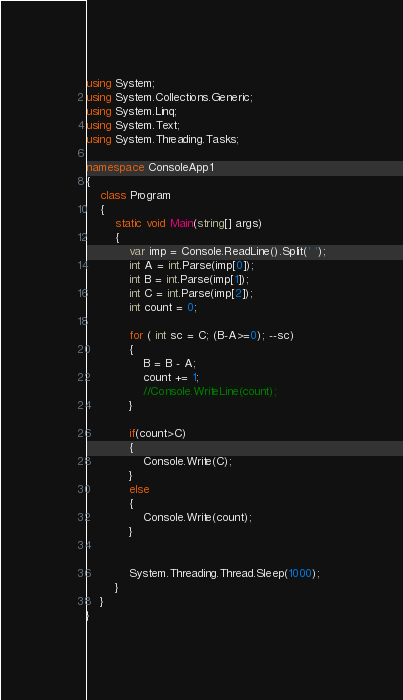<code> <loc_0><loc_0><loc_500><loc_500><_C#_>using System;
using System.Collections.Generic;
using System.Linq;
using System.Text;
using System.Threading.Tasks;

namespace ConsoleApp1
{
    class Program
    {
        static void Main(string[] args)
        {
            var imp = Console.ReadLine().Split(' ');
            int A = int.Parse(imp[0]);
            int B = int.Parse(imp[1]);
            int C = int.Parse(imp[2]);
            int count = 0;

            for ( int sc = C; (B-A>=0); --sc)
            {
                B = B - A;
                count += 1;
                //Console.WriteLine(count);
            }

            if(count>C)
            {
                Console.Write(C);
            }
            else
            {
                Console.Write(count);
            }
           

            System.Threading.Thread.Sleep(1000);
        }
    }
}
</code> 